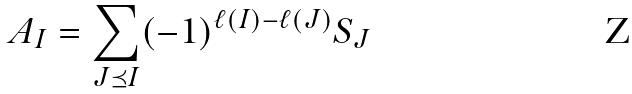<formula> <loc_0><loc_0><loc_500><loc_500>A _ { I } = \sum _ { J \preceq I } ( - 1 ) ^ { \ell ( I ) - \ell ( J ) } S _ { J }</formula> 